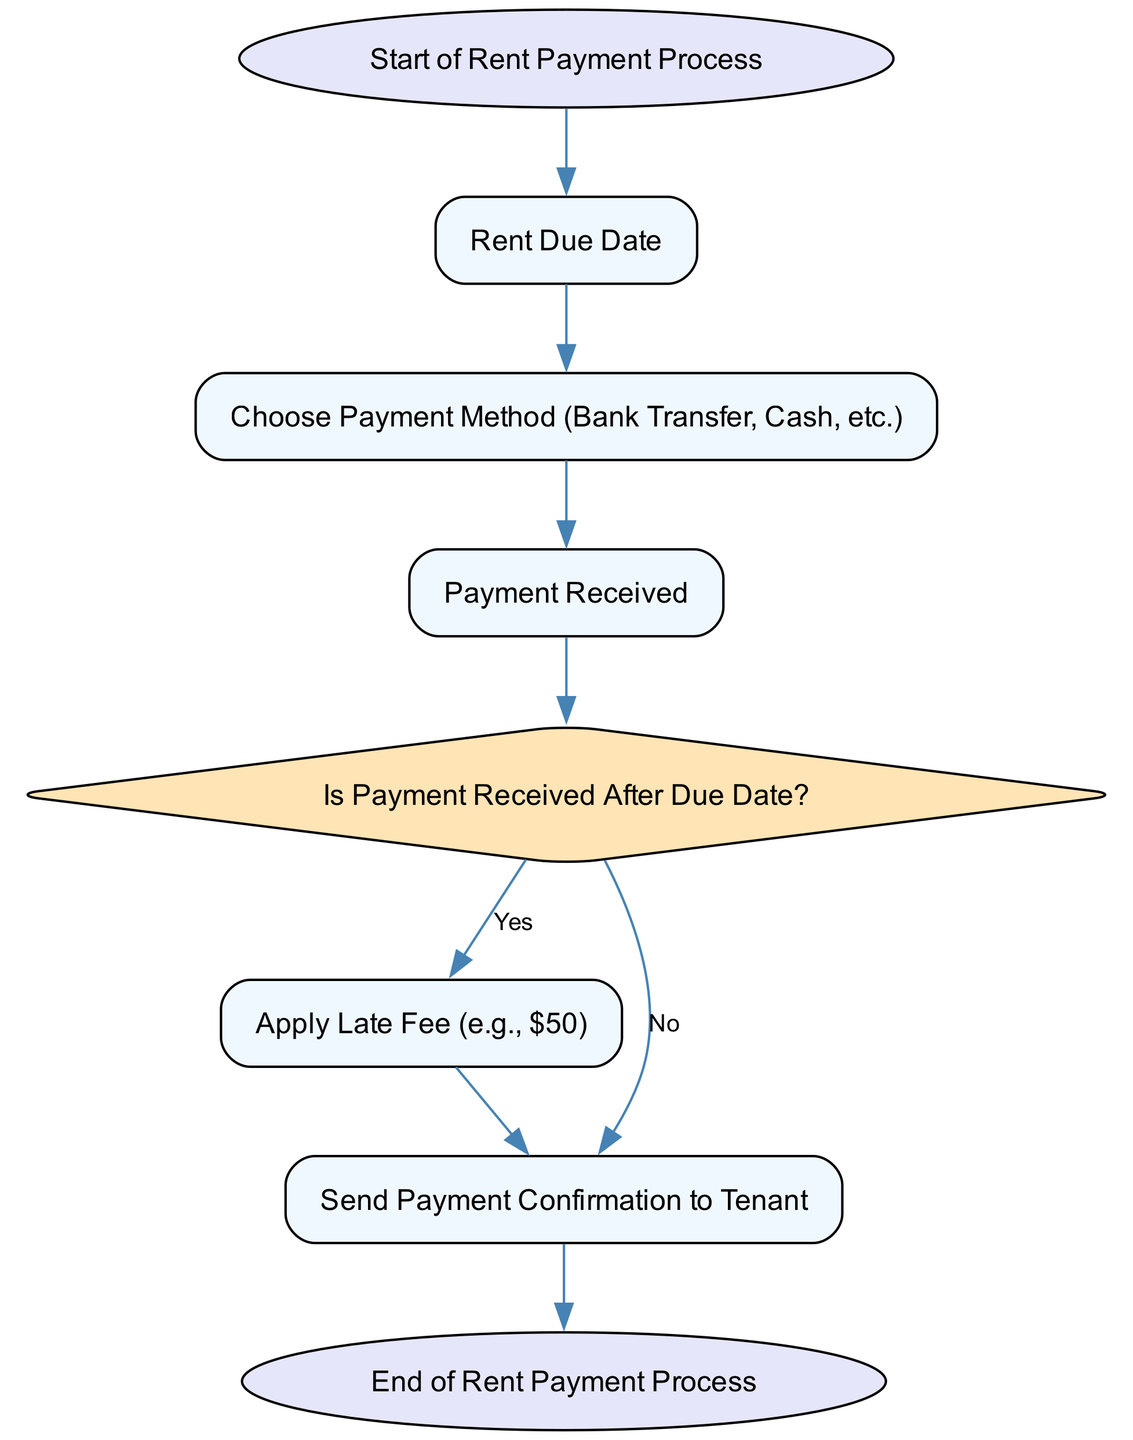What is the first step in the rent payment process? The first step in the flow chart is labeled as "Start of Rent Payment Process." This is indicated at the top of the diagram and marks the initiation of the process.
Answer: Start of Rent Payment Process How many nodes are there in the diagram? By counting the individual elements within the flow chart, there are a total of 8 nodes: start, rent due date, payment method, payment received, late fee trigger, apply late fee, payment confirmation, and end.
Answer: 8 What triggers the late fee? The late fee is triggered when the condition "Is Payment Received After Due Date?" is met. This decision point determines if the late fee will be applied based on whether the payment was received late.
Answer: Is Payment Received After Due Date? What happens if the payment is received on time? If the payment is received on time, the flow goes from the "late fee trigger" node to the "send payment confirmation to tenant" node, skipping the late fee application.
Answer: Send Payment Confirmation to Tenant What fee is applied if the payment is late? The late fee specified in the flow chart is $50, as indicated within the "apply late fee" node. This fee is applied when the condition of receiving the payment after the due date is confirmed.
Answer: $50 What is the last step in the rent payment process? The last step in the flow chart is "End of Rent Payment Process," which signifies the conclusion of the payment process regardless of whether a late fee was applied or not.
Answer: End of Rent Payment Process What are the payment methods mentioned? The flow chart specifies that tenants can choose payment methods, which include bank transfer or cash. This is indicated in the "Choose Payment Method" node.
Answer: Bank Transfer, Cash If payment is received late, which node comes next? If the payment is received late, the process flows to the "apply late fee" node, where the late fee will be assessed before sending a payment confirmation.
Answer: Apply Late Fee How does the diagram denote decision points? The diagram denotes decision points with a diamond shape, as seen in the "late fee trigger" node, clearly showing where a choice must be made in the flow of the process.
Answer: Diamond shape 